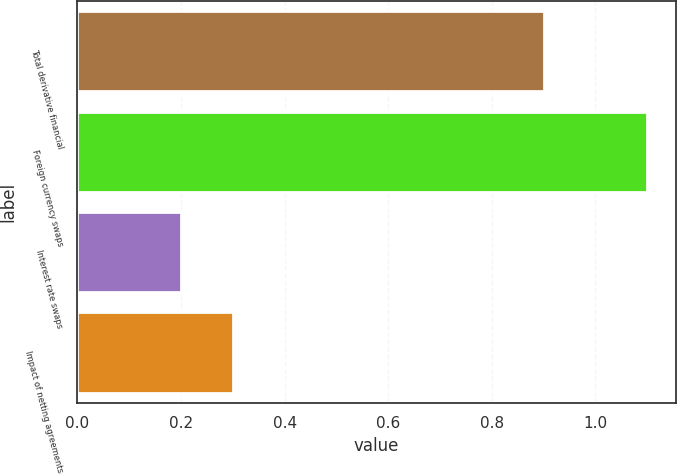Convert chart. <chart><loc_0><loc_0><loc_500><loc_500><bar_chart><fcel>Total derivative financial<fcel>Foreign currency swaps<fcel>Interest rate swaps<fcel>Impact of netting agreements<nl><fcel>0.9<fcel>1.1<fcel>0.2<fcel>0.3<nl></chart> 